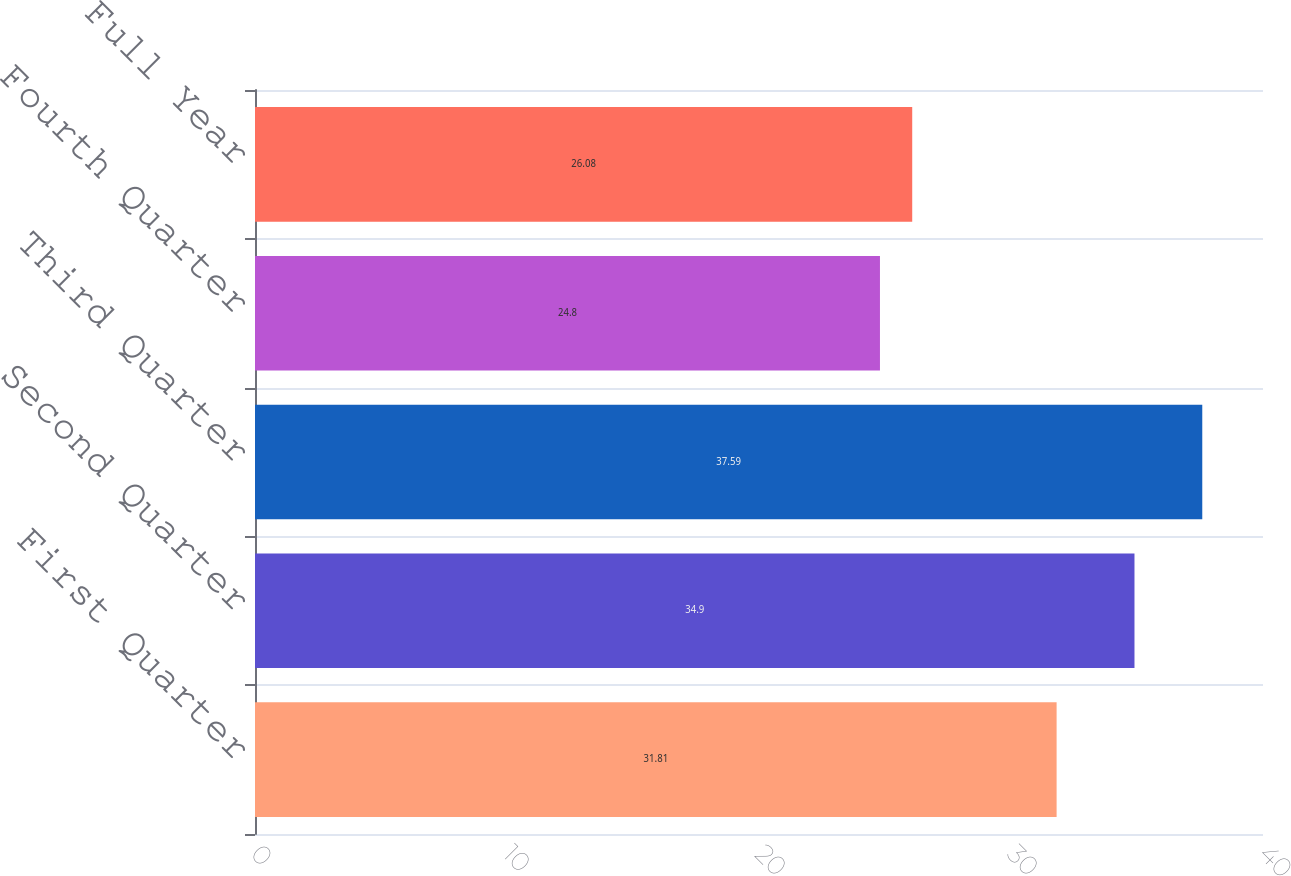Convert chart. <chart><loc_0><loc_0><loc_500><loc_500><bar_chart><fcel>First Quarter<fcel>Second Quarter<fcel>Third Quarter<fcel>Fourth Quarter<fcel>Full Year<nl><fcel>31.81<fcel>34.9<fcel>37.59<fcel>24.8<fcel>26.08<nl></chart> 